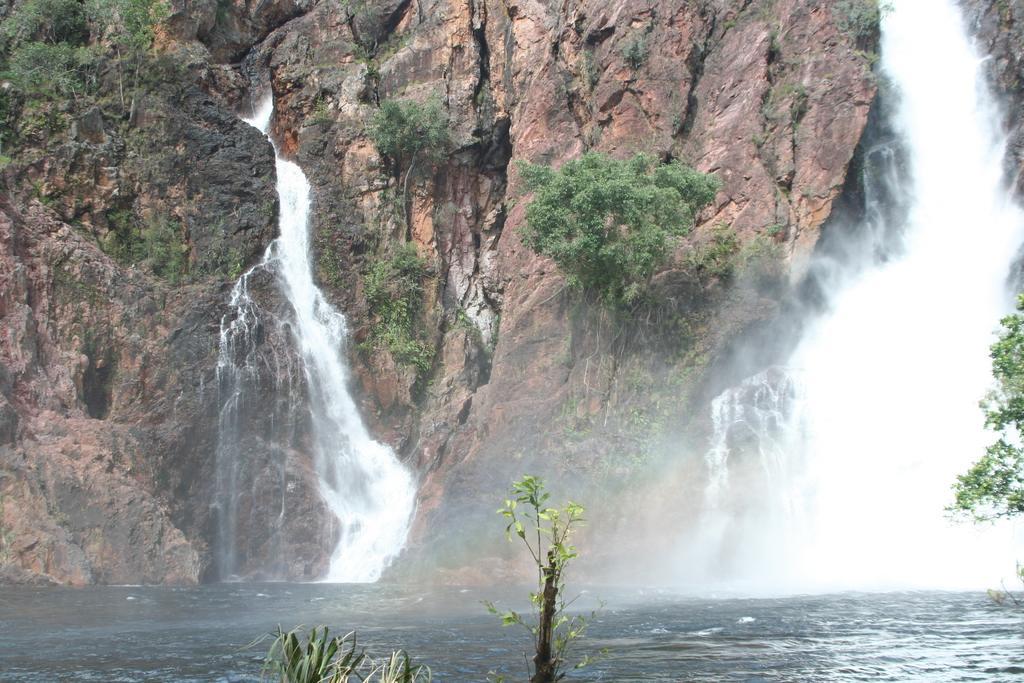Describe this image in one or two sentences. In the image we can see waterfall, trees and big rocks. 